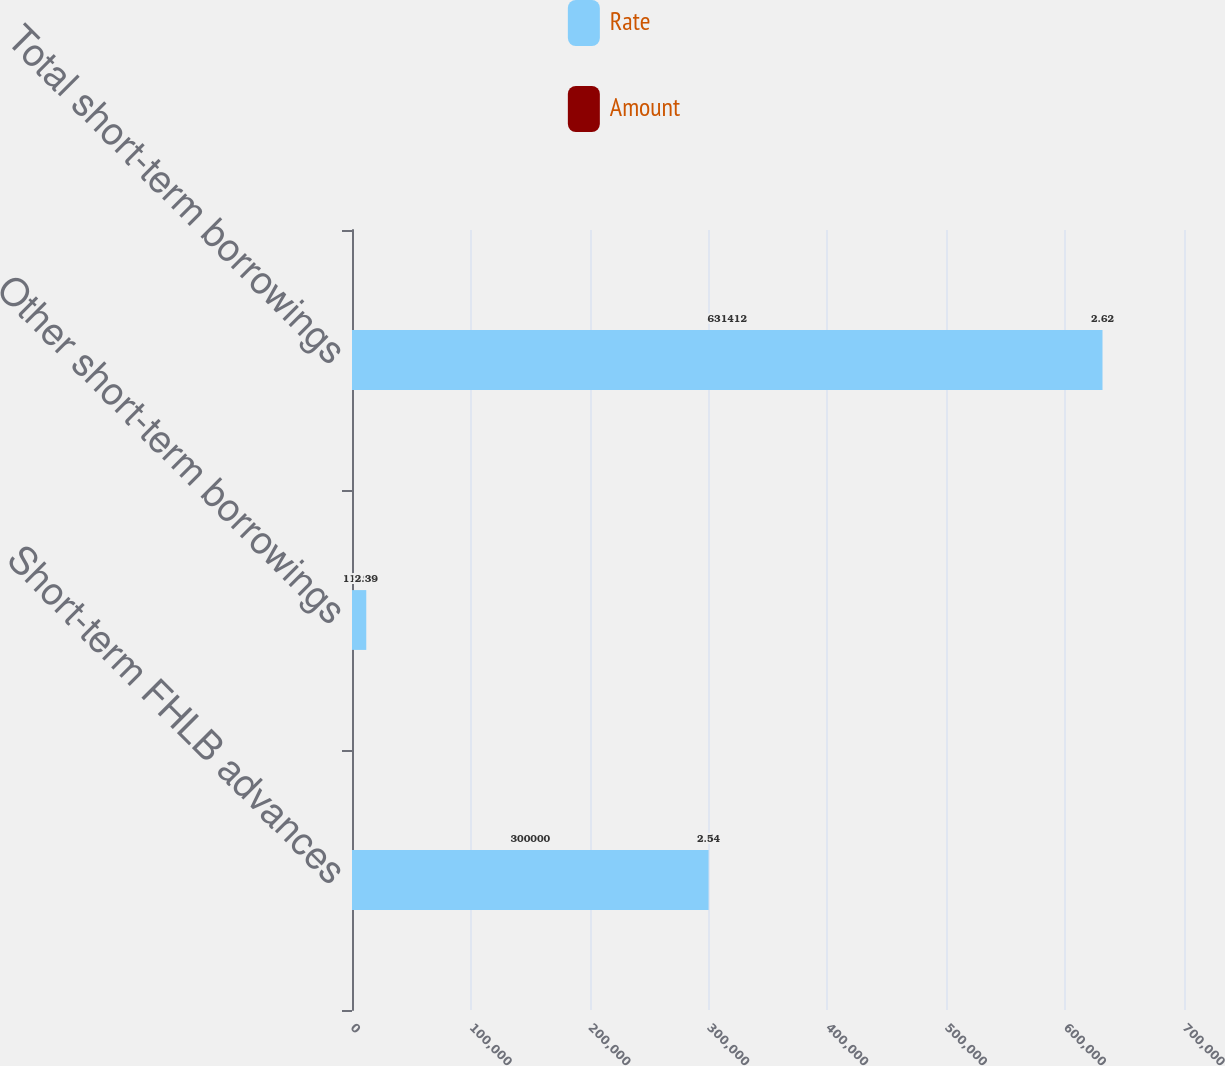<chart> <loc_0><loc_0><loc_500><loc_500><stacked_bar_chart><ecel><fcel>Short-term FHLB advances<fcel>Other short-term borrowings<fcel>Total short-term borrowings<nl><fcel>Rate<fcel>300000<fcel>11998<fcel>631412<nl><fcel>Amount<fcel>2.54<fcel>2.39<fcel>2.62<nl></chart> 